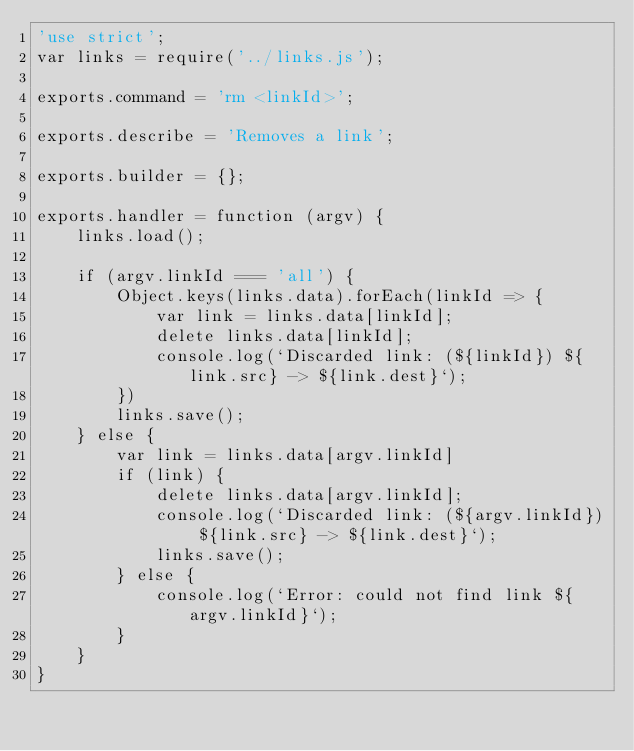<code> <loc_0><loc_0><loc_500><loc_500><_JavaScript_>'use strict';
var links = require('../links.js');

exports.command = 'rm <linkId>';

exports.describe = 'Removes a link';

exports.builder = {};

exports.handler = function (argv) {
	links.load();

	if (argv.linkId === 'all') {
		Object.keys(links.data).forEach(linkId => {
			var link = links.data[linkId];
			delete links.data[linkId];
			console.log(`Discarded link: (${linkId}) ${link.src} -> ${link.dest}`);
		})
		links.save();
	} else {
		var link = links.data[argv.linkId]
		if (link) {
			delete links.data[argv.linkId];
			console.log(`Discarded link: (${argv.linkId}) ${link.src} -> ${link.dest}`);
			links.save();
		} else {
			console.log(`Error: could not find link ${argv.linkId}`);
		}
	}
}
</code> 